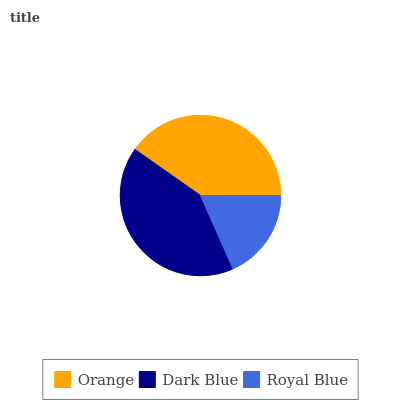Is Royal Blue the minimum?
Answer yes or no. Yes. Is Dark Blue the maximum?
Answer yes or no. Yes. Is Dark Blue the minimum?
Answer yes or no. No. Is Royal Blue the maximum?
Answer yes or no. No. Is Dark Blue greater than Royal Blue?
Answer yes or no. Yes. Is Royal Blue less than Dark Blue?
Answer yes or no. Yes. Is Royal Blue greater than Dark Blue?
Answer yes or no. No. Is Dark Blue less than Royal Blue?
Answer yes or no. No. Is Orange the high median?
Answer yes or no. Yes. Is Orange the low median?
Answer yes or no. Yes. Is Royal Blue the high median?
Answer yes or no. No. Is Royal Blue the low median?
Answer yes or no. No. 